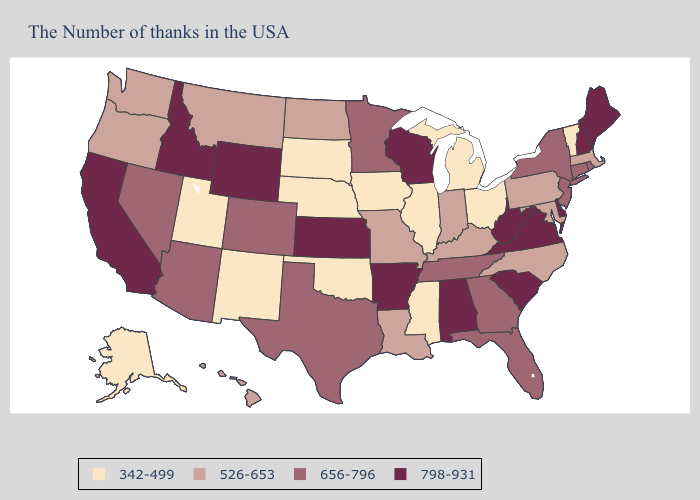Which states have the highest value in the USA?
Short answer required. Maine, New Hampshire, Delaware, Virginia, South Carolina, West Virginia, Alabama, Wisconsin, Arkansas, Kansas, Wyoming, Idaho, California. Does Alabama have a higher value than Oklahoma?
Give a very brief answer. Yes. What is the value of North Dakota?
Give a very brief answer. 526-653. Among the states that border Indiana , which have the lowest value?
Quick response, please. Ohio, Michigan, Illinois. Does West Virginia have the lowest value in the USA?
Quick response, please. No. Among the states that border California , does Oregon have the lowest value?
Be succinct. Yes. Name the states that have a value in the range 342-499?
Quick response, please. Vermont, Ohio, Michigan, Illinois, Mississippi, Iowa, Nebraska, Oklahoma, South Dakota, New Mexico, Utah, Alaska. What is the lowest value in the West?
Quick response, please. 342-499. Which states have the highest value in the USA?
Be succinct. Maine, New Hampshire, Delaware, Virginia, South Carolina, West Virginia, Alabama, Wisconsin, Arkansas, Kansas, Wyoming, Idaho, California. What is the value of Texas?
Quick response, please. 656-796. Name the states that have a value in the range 342-499?
Quick response, please. Vermont, Ohio, Michigan, Illinois, Mississippi, Iowa, Nebraska, Oklahoma, South Dakota, New Mexico, Utah, Alaska. Among the states that border Michigan , which have the lowest value?
Short answer required. Ohio. Name the states that have a value in the range 342-499?
Give a very brief answer. Vermont, Ohio, Michigan, Illinois, Mississippi, Iowa, Nebraska, Oklahoma, South Dakota, New Mexico, Utah, Alaska. What is the lowest value in the South?
Give a very brief answer. 342-499. Which states hav the highest value in the West?
Short answer required. Wyoming, Idaho, California. 